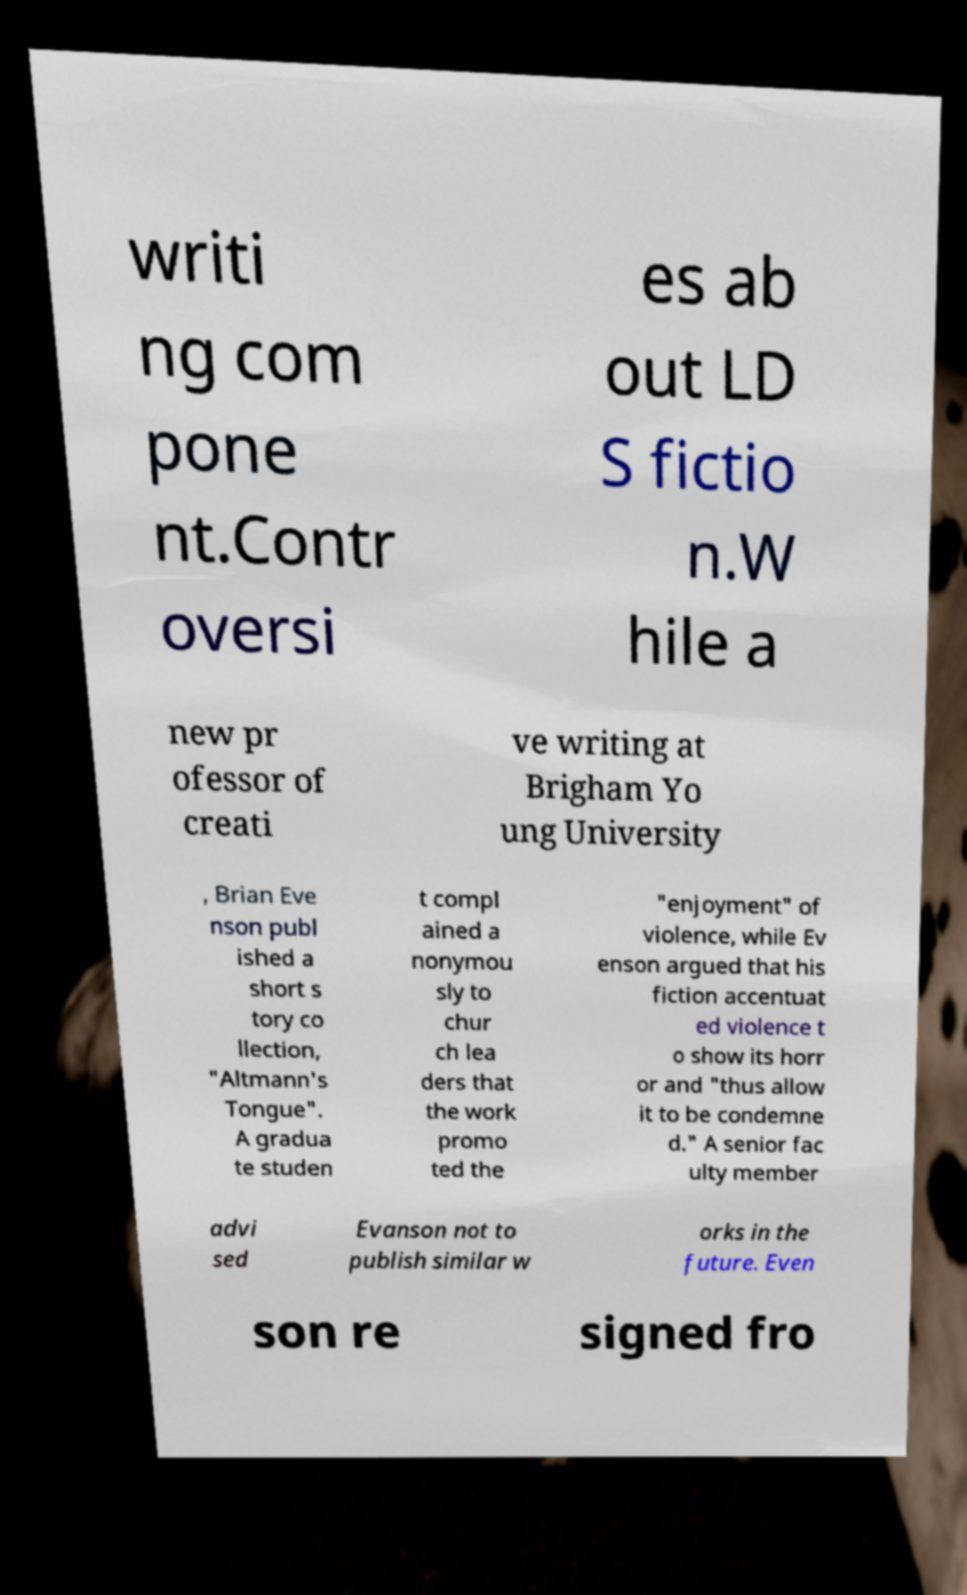I need the written content from this picture converted into text. Can you do that? writi ng com pone nt.Contr oversi es ab out LD S fictio n.W hile a new pr ofessor of creati ve writing at Brigham Yo ung University , Brian Eve nson publ ished a short s tory co llection, "Altmann's Tongue". A gradua te studen t compl ained a nonymou sly to chur ch lea ders that the work promo ted the "enjoyment" of violence, while Ev enson argued that his fiction accentuat ed violence t o show its horr or and "thus allow it to be condemne d." A senior fac ulty member advi sed Evanson not to publish similar w orks in the future. Even son re signed fro 